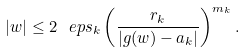Convert formula to latex. <formula><loc_0><loc_0><loc_500><loc_500>| w | \leq 2 \ e p s _ { k } \left ( \frac { r _ { k } } { | g ( w ) - a _ { k } | } \right ) ^ { m _ { k } } .</formula> 